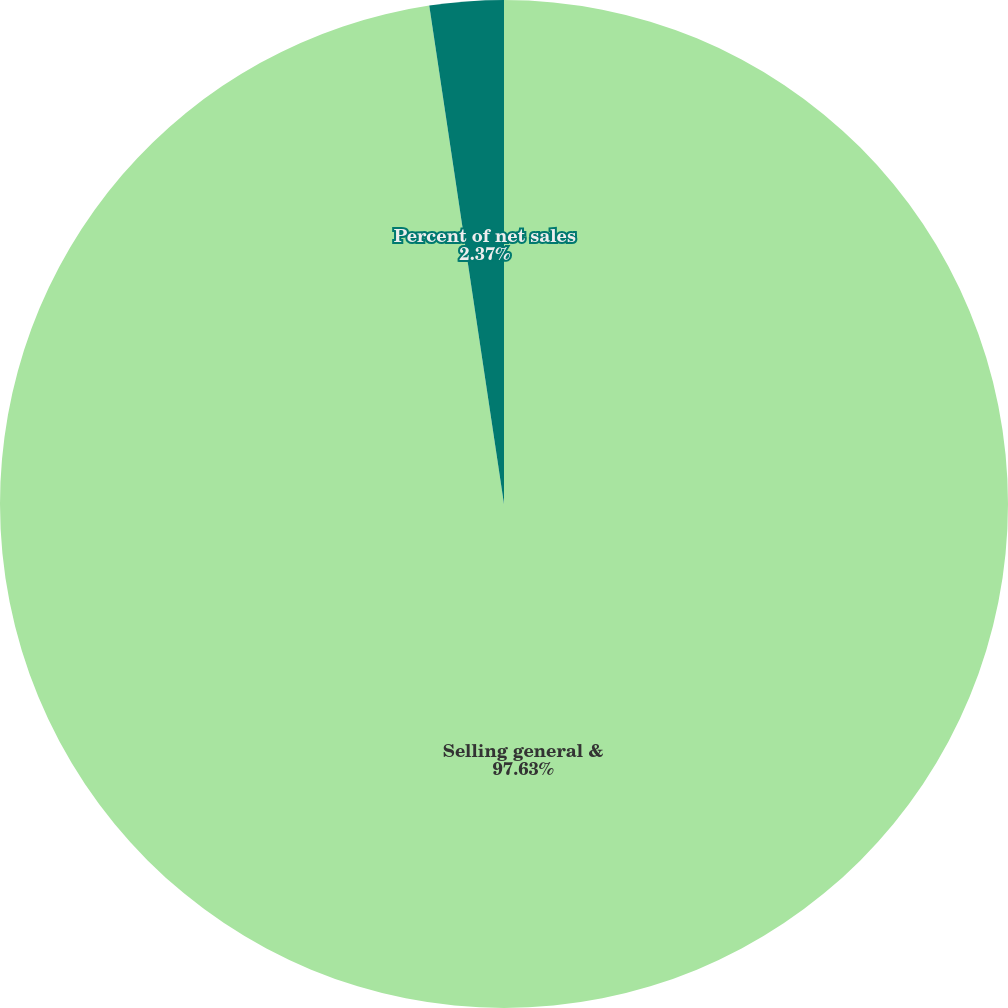Convert chart to OTSL. <chart><loc_0><loc_0><loc_500><loc_500><pie_chart><fcel>Selling general &<fcel>Percent of net sales<nl><fcel>97.63%<fcel>2.37%<nl></chart> 